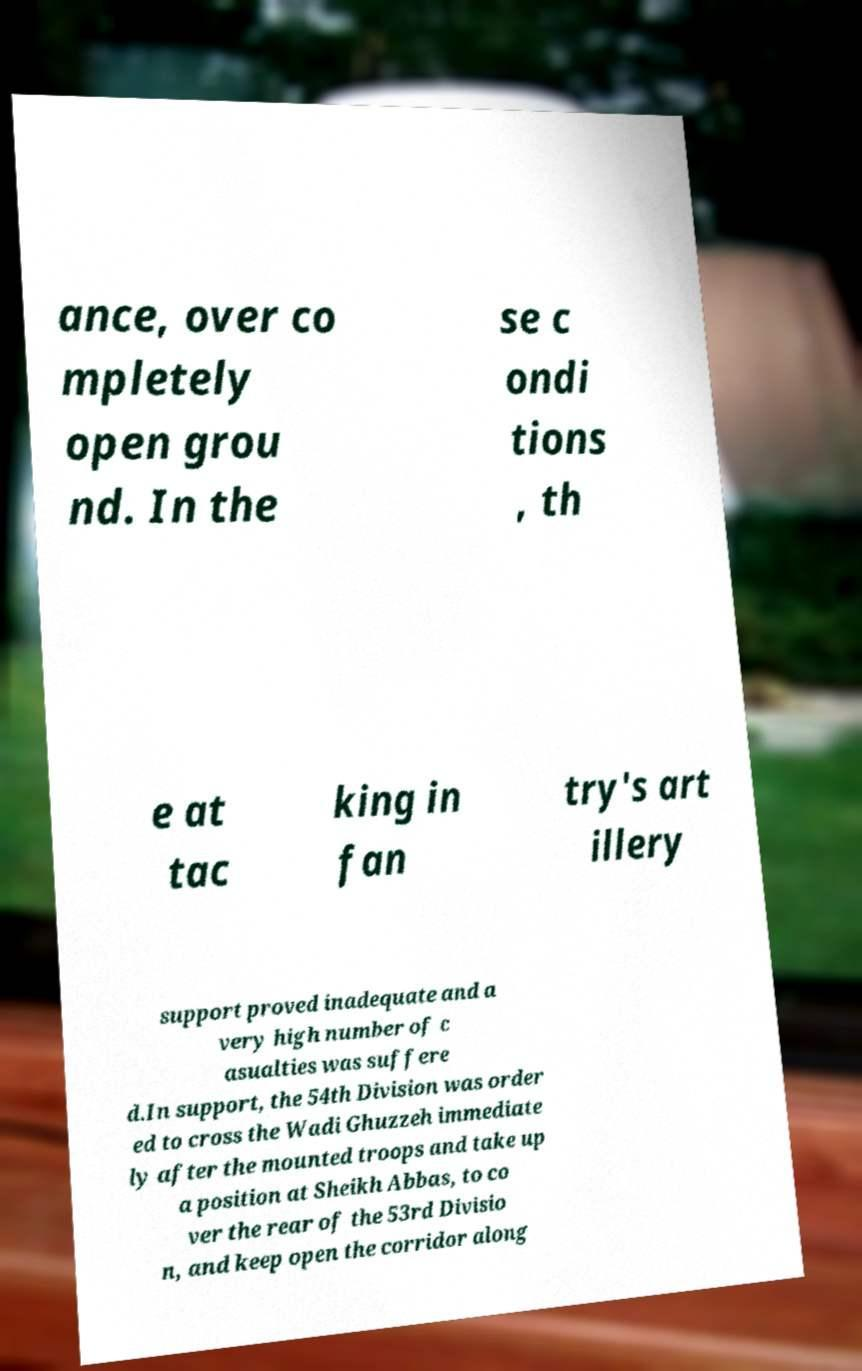There's text embedded in this image that I need extracted. Can you transcribe it verbatim? ance, over co mpletely open grou nd. In the se c ondi tions , th e at tac king in fan try's art illery support proved inadequate and a very high number of c asualties was suffere d.In support, the 54th Division was order ed to cross the Wadi Ghuzzeh immediate ly after the mounted troops and take up a position at Sheikh Abbas, to co ver the rear of the 53rd Divisio n, and keep open the corridor along 